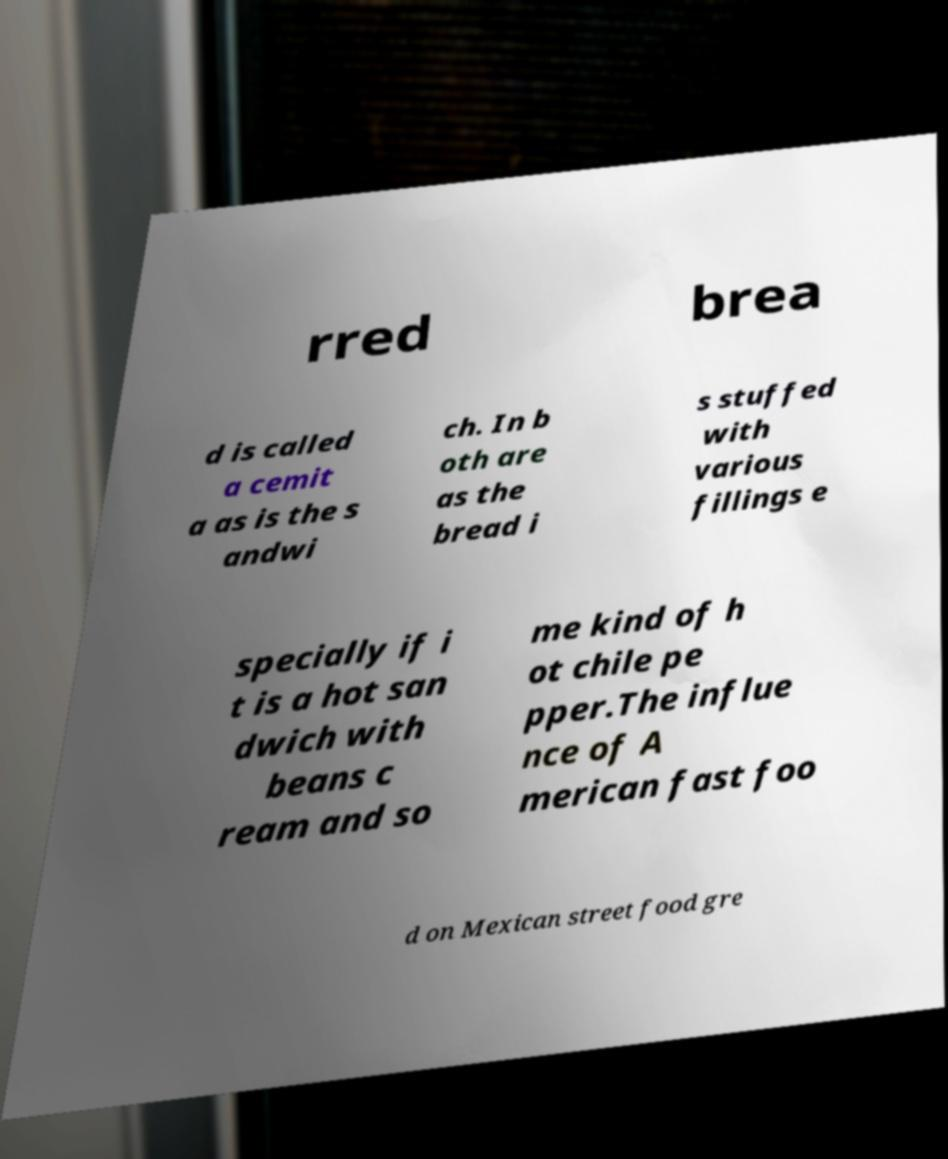There's text embedded in this image that I need extracted. Can you transcribe it verbatim? rred brea d is called a cemit a as is the s andwi ch. In b oth are as the bread i s stuffed with various fillings e specially if i t is a hot san dwich with beans c ream and so me kind of h ot chile pe pper.The influe nce of A merican fast foo d on Mexican street food gre 